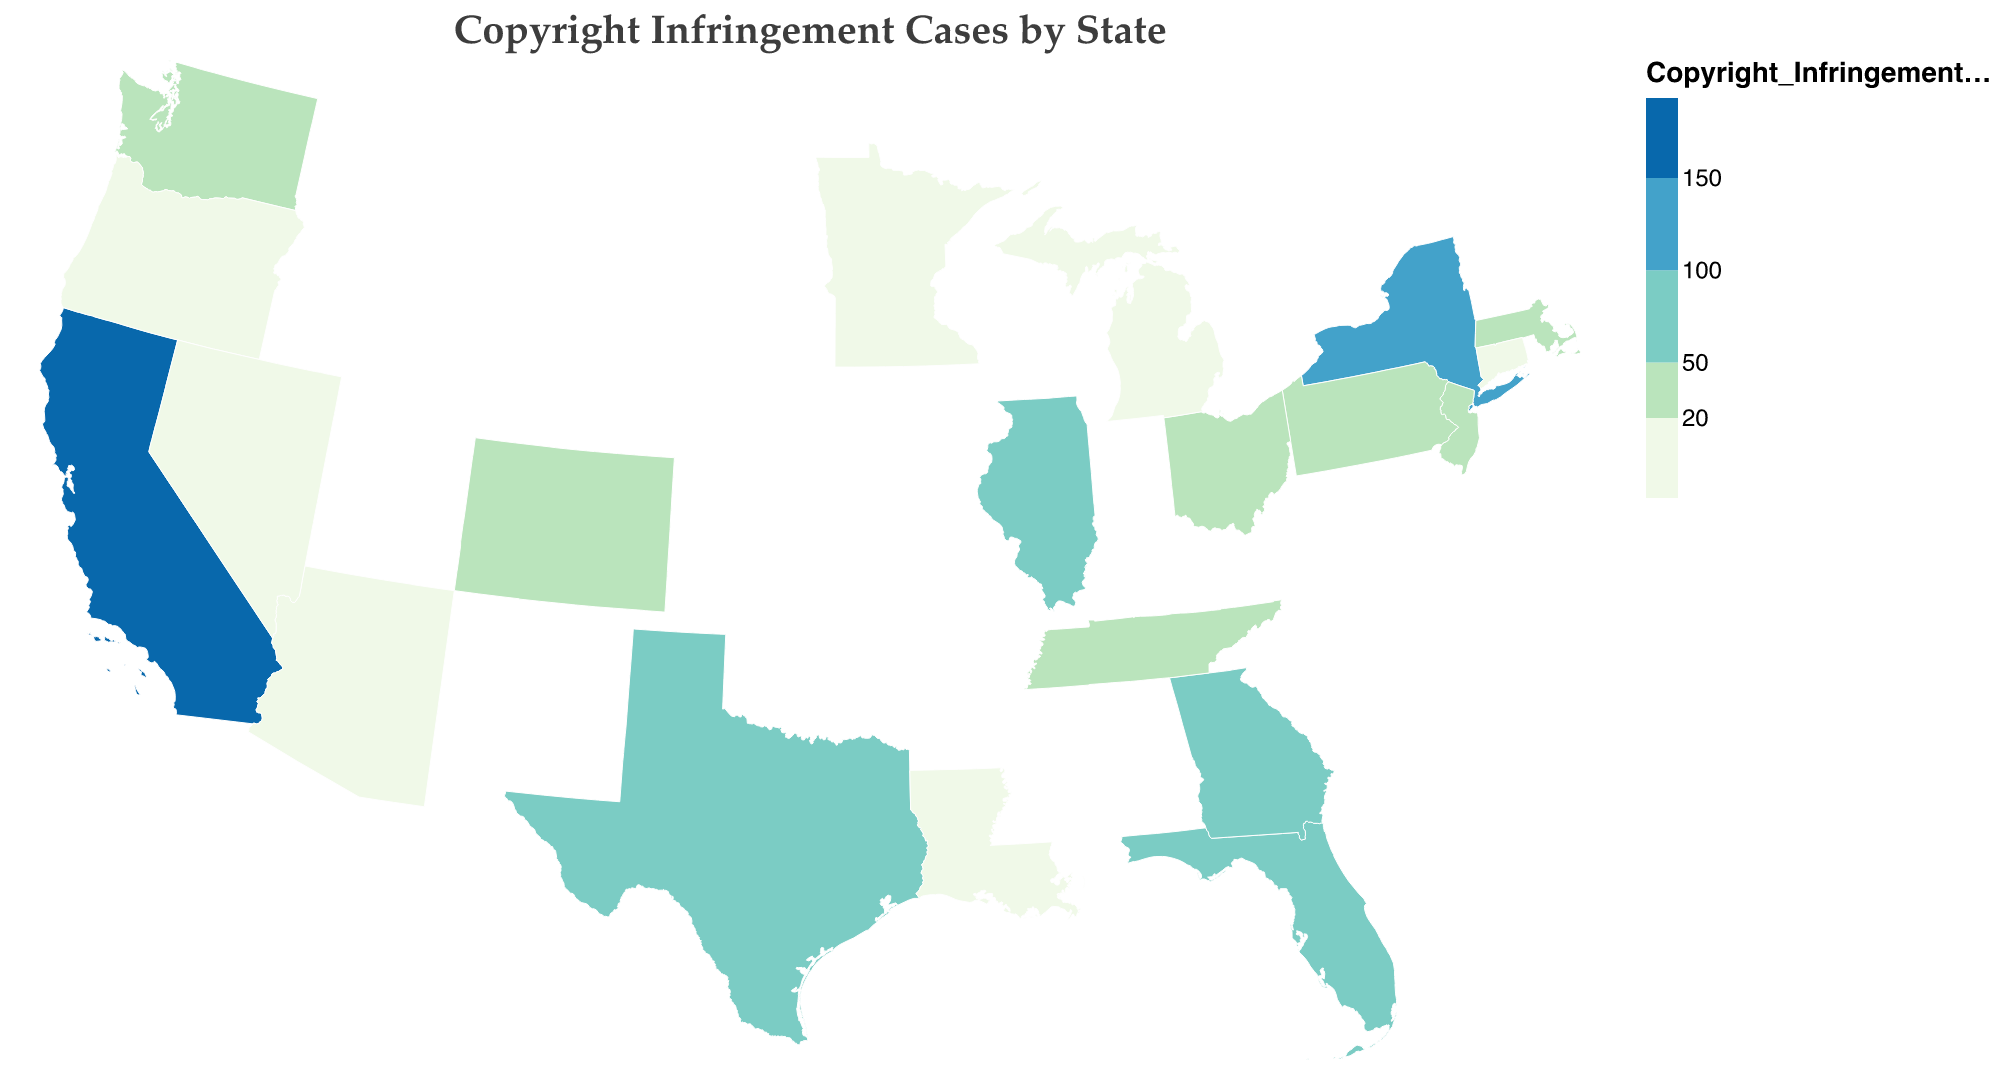What state has the highest number of copyright infringement cases? The state with the highest number of copyright infringement cases is represented by the darkest color on the plot. According to the figure, California has the highest number of cases.
Answer: California Which three states have the fewest number of copyright infringement cases? To find the states with the fewest cases, look for the states with the lightest colors representing the lowest category. According to the figure, the states with the fewest cases are Connecticut, Louisiana, and Minnesota.
Answer: Connecticut, Louisiana, and Minnesota How many states have more than 50 copyright infringement cases? Identify the states colored in shades darker than the one representing 50 cases. The states with more than 50 cases are California, New York, Florida, Texas, Illinois, and Georgia, making a total of 6 states.
Answer: 6 What is the total number of copyright infringement cases in California, New York, and Florida combined? Add the number of cases in California (187), New York (143), and Florida (92). The calculation is 187 + 143 + 92 = 422.
Answer: 422 Which states have a similar number of copyright infringement cases, with a difference of no more than 5 cases? Look for states with case numbers close to each other on the plot. Texas (78) and Illinois (65) have a difference of 13, but Tennessee (47) and Georgia (53) have a difference of 6, which is inconsistent with the criteria. Correct pairings based on visual data may not fit the criteria perfectly. More accurate comparisons need further review.
Answer: Requires further review What color represents states with fewer than 20 copyright infringement cases? Observing the plot’s color scale, states with fewer than 20 cases are in the lightest shade of the gradient. These states include Michigan, Oregon, Arizona, Nevada, Louisiana, Connecticut, and Minnesota.
Answer: Light green Is there a significant difference in the number of cases between Texas and Illinois? Compare the two states’ case numbers, where Texas has 78 cases and Illinois has 65 cases. The difference is 78 - 65 = 13, which is relatively significant compared to other state differences.
Answer: Yes, 13 cases Which state has approximately double the number of cases compared to Pennsylvania? Pennsylvania has 31 cases. To find a state with roughly double that, look for a state with around 62 cases. Illinois has 65 cases, which is close to double that of Pennsylvania.
Answer: Illinois Analyze the concentration of cases in coastal vs. inland states. Coastal states like California, New York, and Florida show high concentrations of cases, depicted by darker colors. Inland states have lighter shades, generally indicating fewer cases. High-case states tend to be coastal, demonstrating a correlation between coastal locations and higher infringement cases.
Answer: Coastal states have higher concentrations What pattern can be observed from the geographic distribution of copyright infringement cases by region? Analyzing the map reveals that copyright infringement cases are more concentrated in coastal regions, particularly in states like California, New York, and Florida. Inland states tend to have fewer cases, suggesting higher activity in entertainment hubs.
Answer: Coastal regions have more cases 